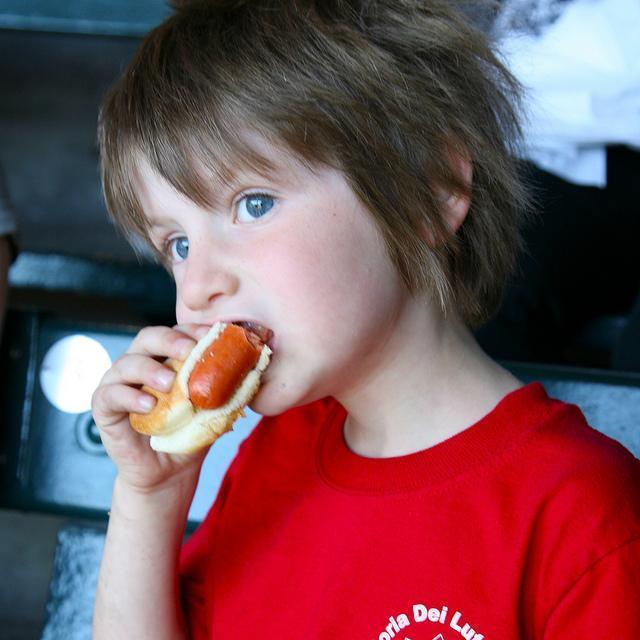How many people are there?
Give a very brief answer. 1. 